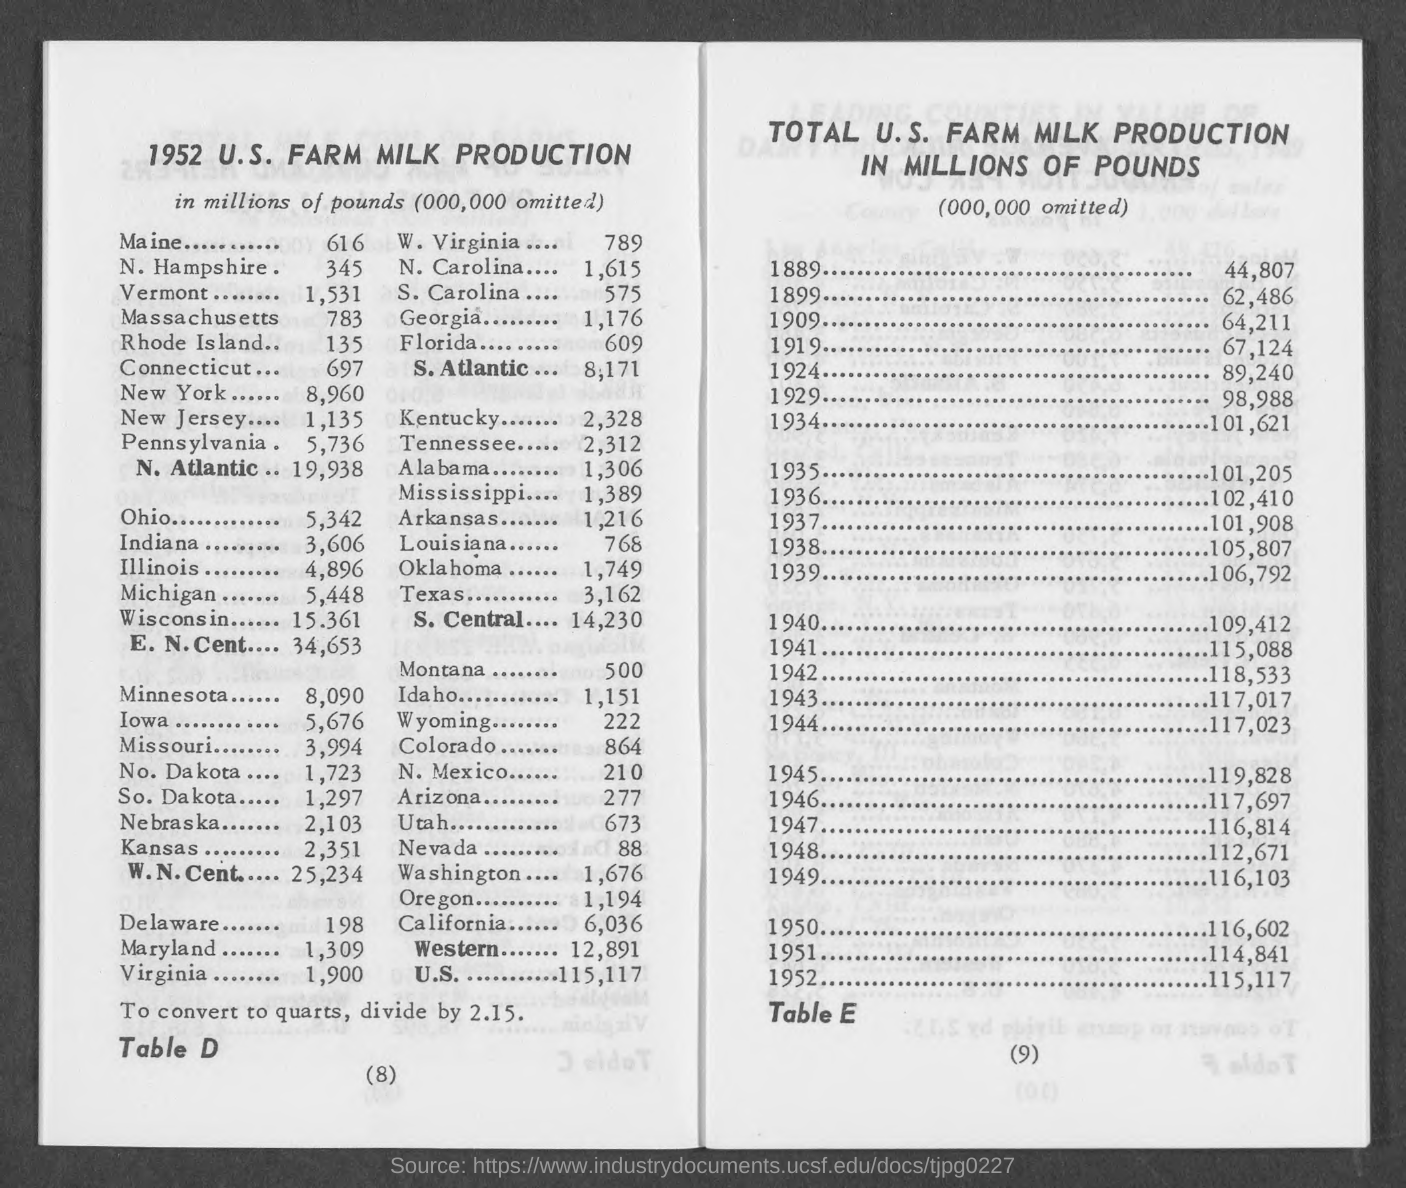Draw attention to some important aspects in this diagram. In 1952, the milk production in Vermont, as reported by the U.S. Farm, was 1,531 million pounds. In 1952, the milk production in Massachusetts, specifically in the U.S. Farm, reached 783 million pounds. In 1952, the milk production in the state of Maine, specifically in the U.S. Farm sector, was approximately 616 million pounds. In 1952, the milk production in New Jersey, specifically in the U.S. Farm sector, was approximately 1,135 million pounds. In 1952, the milk production in Indiana, United States, from farms was 3,606 million pounds. 